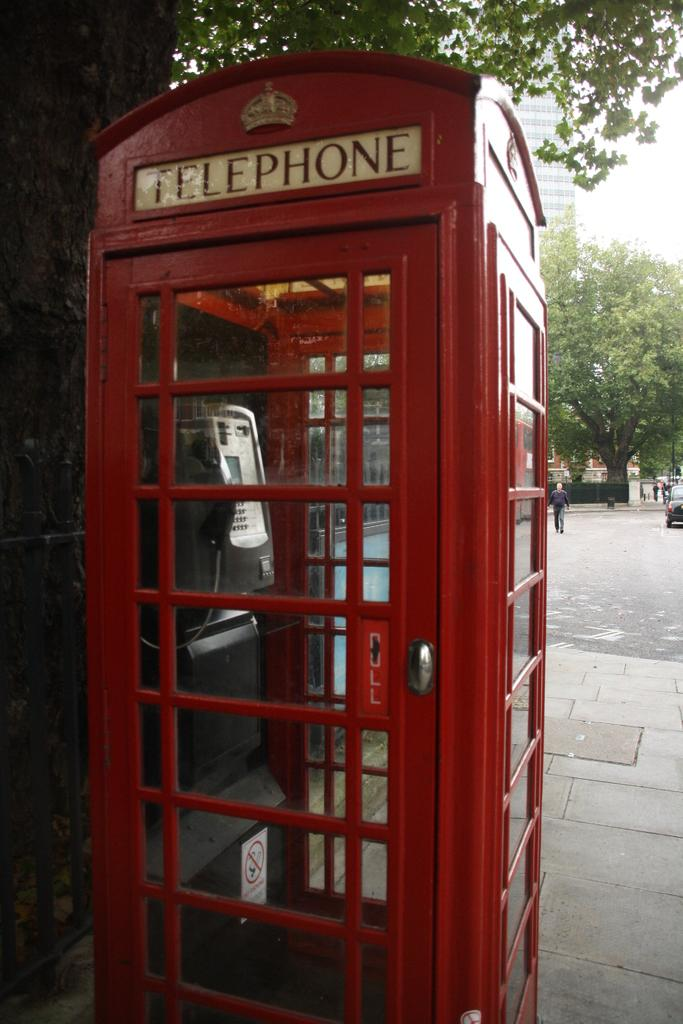<image>
Render a clear and concise summary of the photo. A structure is red with the word Telephone on a white sign above a paneled door. 